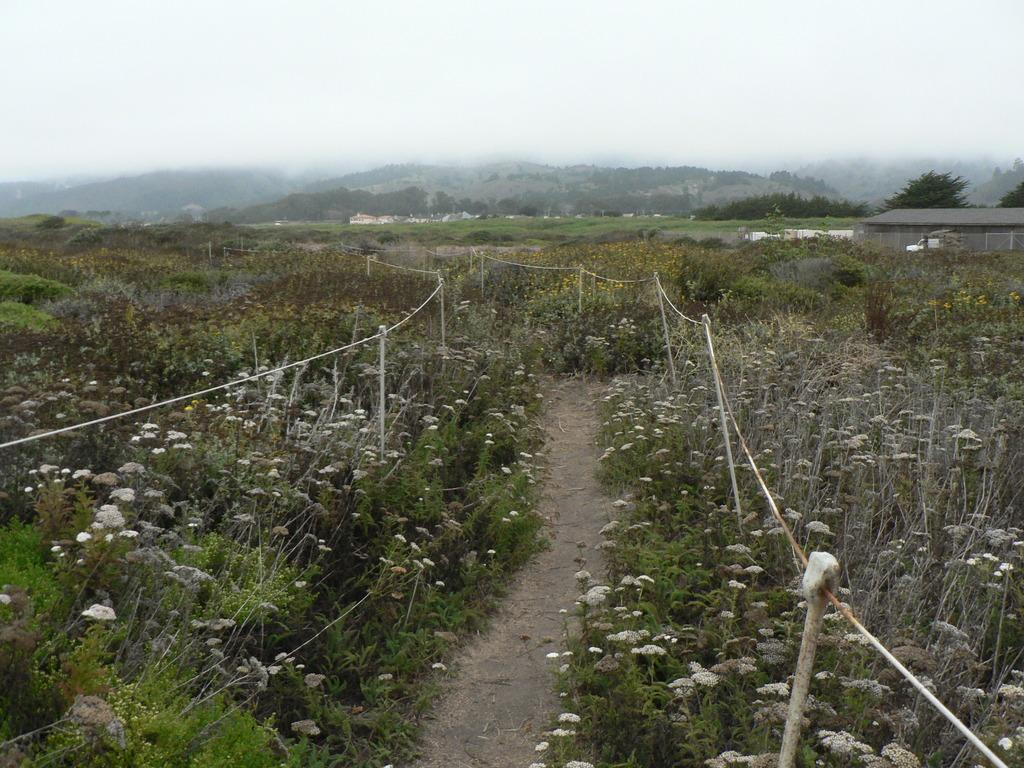What type of flora can be seen in the image? There are flowers in the image. What colors are the flowers? The flowers are in white and yellow colors. What other natural elements are present in the image? There are trees in the image. What color are the trees? The trees are in green color. What part of the natural environment is visible in the image? The sky is visible in the image. What color is the sky? The sky is in white color. Can you tell me where the mother is standing in the image? There is no mother present in the image; it features flowers, trees, and the sky. What type of building can be seen in the image? There is no building present in the image; it features flowers, trees, and the sky. 